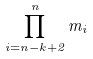Convert formula to latex. <formula><loc_0><loc_0><loc_500><loc_500>\prod _ { i = n - k + 2 } ^ { n } m _ { i }</formula> 